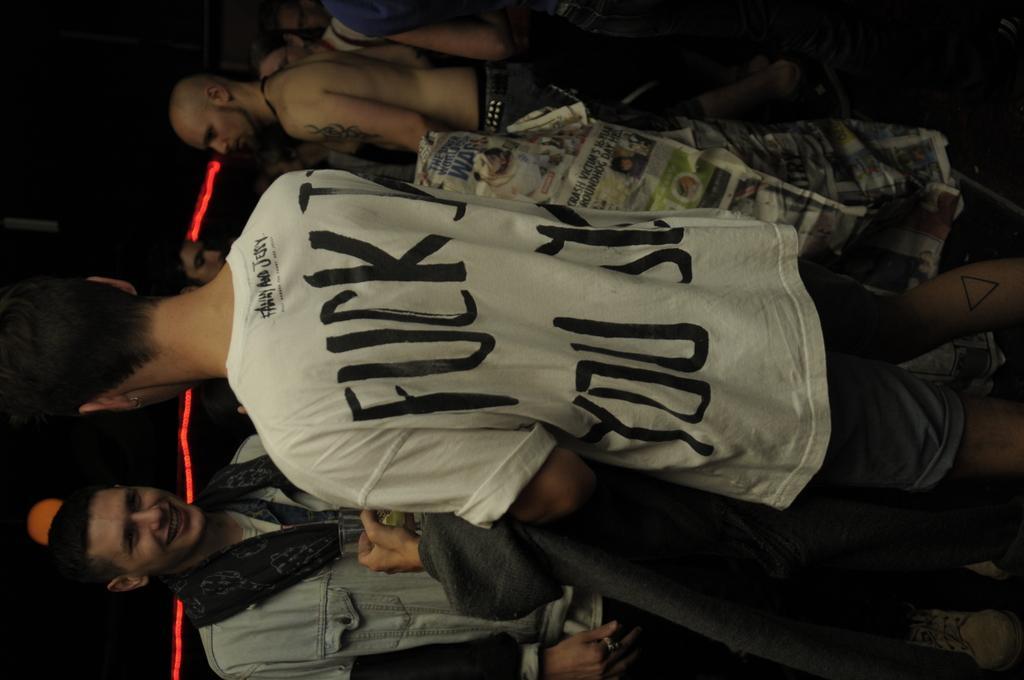Can you describe this image briefly? There are group of people standing. This looks like a newspaper. I think this is a light, which is red in color. The background looks dark. 